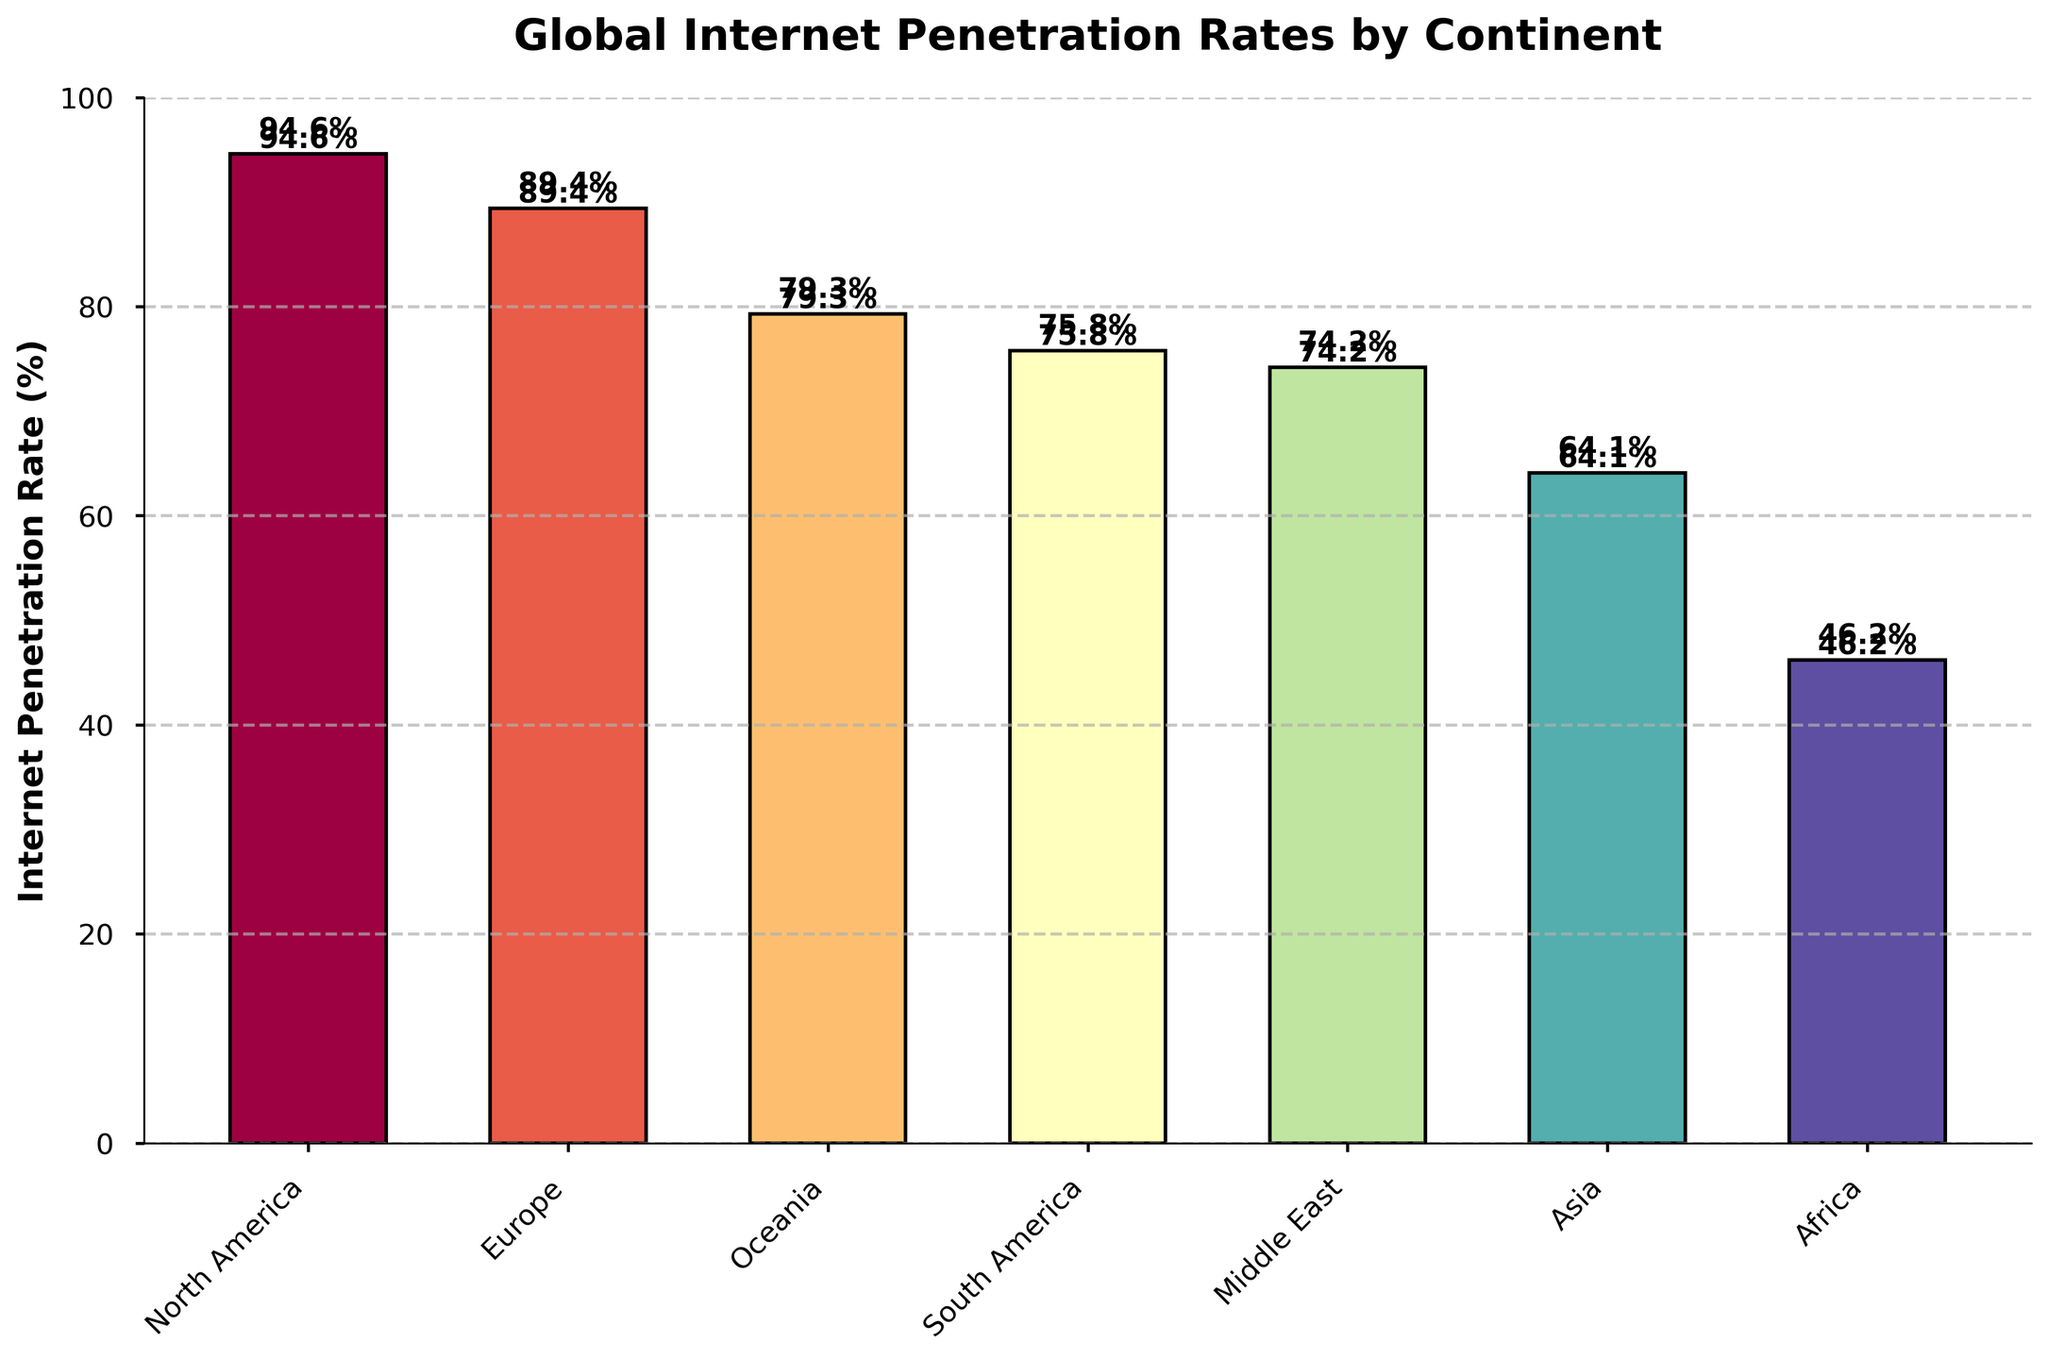Which continent has the highest internet penetration rate? To find the continent with the highest internet penetration rate, look at the bar with the greatest height. In this case, North America has the tallest bar, which corresponds to an internet penetration rate of 94.6%.
Answer: North America Which continent has the lowest internet penetration rate? Locate the bar with the smallest height to determine the lowest internet penetration rate. The shortest bar belongs to Africa, with a penetration rate of 46.2%.
Answer: Africa What is the difference in internet penetration rate between North America and Africa? To find the difference, subtract the internet penetration rate of Africa from that of North America: 94.6% - 46.2% = 48.4%.
Answer: 48.4% Rank the continents from highest to lowest internet penetration rate. Compare the heights of the bars and list the continents in descending order: North America (94.6%), Europe (89.4%), Oceania (79.3%), South America (75.8%), Middle East (74.2%), Asia (64.1%), Africa (46.2%).
Answer: North America, Europe, Oceania, South America, Middle East, Asia, Africa What is the total internet penetration rate if you sum the rates for Europe and Asia? Add the internet penetration rates of Europe and Asia: 89.4% + 64.1% = 153.5%.
Answer: 153.5% Which continents have internet penetration rates above 70%? Identify the bars with heights greater than 70%: North America (94.6%), Europe (89.4%), Oceania (79.3%), South America (75.8%), and Middle East (74.2%).
Answer: North America, Europe, Oceania, South America, Middle East What is the average internet penetration rate across all continents? To find the average, sum the internet penetration rates of all continents and divide by the number of continents: (94.6 + 89.4 + 79.3 + 75.8 + 74.2 + 64.1 + 46.2) / 7 = 74.76%.
Answer: 74.76% How much higher is the internet penetration rate in Europe compared to Asia? Subtract the internet penetration rate of Asia from that of Europe: 89.4% - 64.1% = 25.3%.
Answer: 25.3% How many continents have internet penetration rates below 80%? Count the bars with heights less than 80%. There are four continents: South America, Middle East, Asia, and Africa.
Answer: 4 What is the combined internet penetration rate for Oceania, South America, and the Middle East? Add the internet penetration rates of these three continents: 79.3% + 75.8% + 74.2% = 229.3%.
Answer: 229.3% 